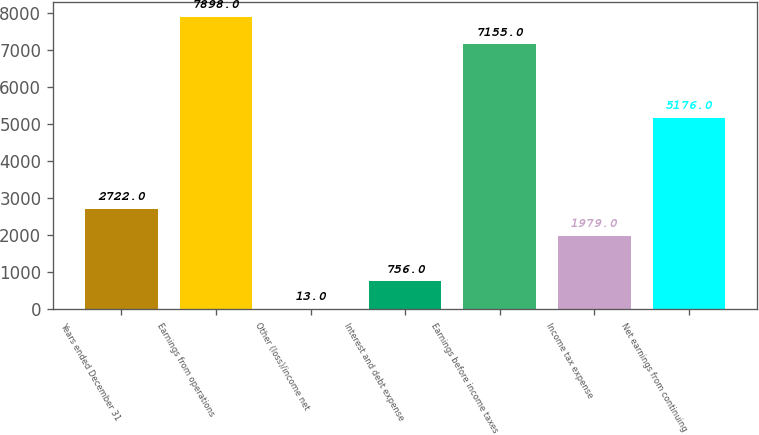Convert chart. <chart><loc_0><loc_0><loc_500><loc_500><bar_chart><fcel>Years ended December 31<fcel>Earnings from operations<fcel>Other (loss)/income net<fcel>Interest and debt expense<fcel>Earnings before income taxes<fcel>Income tax expense<fcel>Net earnings from continuing<nl><fcel>2722<fcel>7898<fcel>13<fcel>756<fcel>7155<fcel>1979<fcel>5176<nl></chart> 